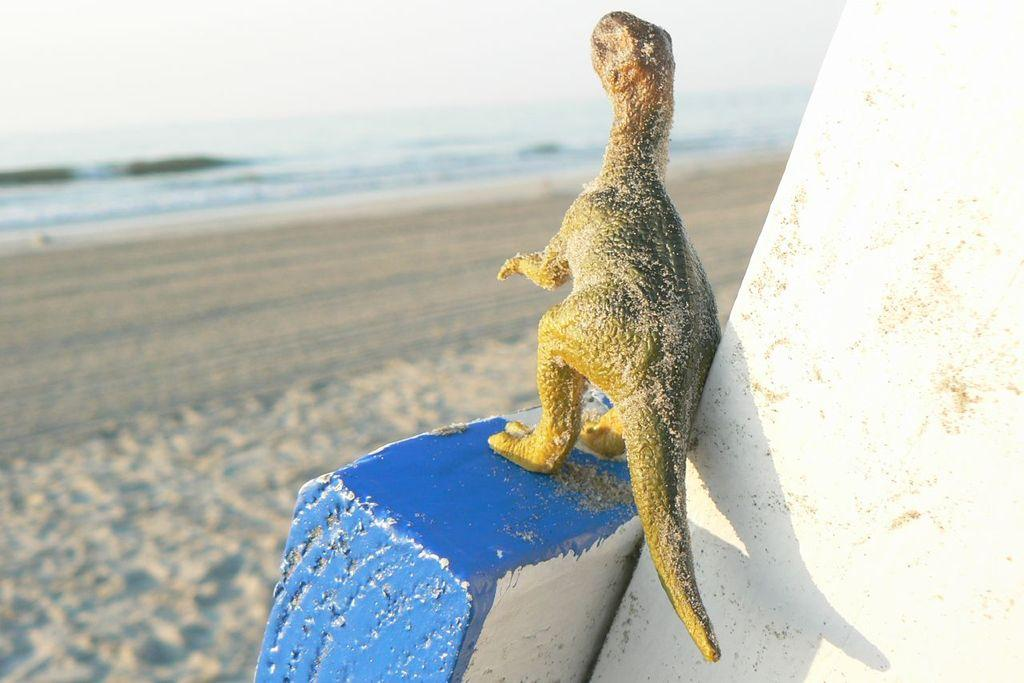What type of object is hanging on the wall in the image? There is an animal toy on the wall in the image. What color is the wall that the animal toy is hanging on? The wall is painted blue. What type of terrain can be seen in the image? There is land visible in the image. What natural elements are visible at the top of the image? There is water and the sky visible at the top of the image. How many chairs can be seen in the image? There are no chairs visible in the image. What type of boats are present in the water at the top of the image? There are no boats present in the image; only water and the sky are visible at the top. 